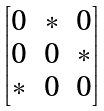Convert formula to latex. <formula><loc_0><loc_0><loc_500><loc_500>\begin{bmatrix} 0 & * & 0 \\ 0 & 0 & * \\ * & 0 & 0 \end{bmatrix}</formula> 